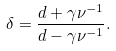<formula> <loc_0><loc_0><loc_500><loc_500>\delta = \frac { d + \gamma \nu ^ { - 1 } } { d - \gamma \nu ^ { - 1 } } .</formula> 